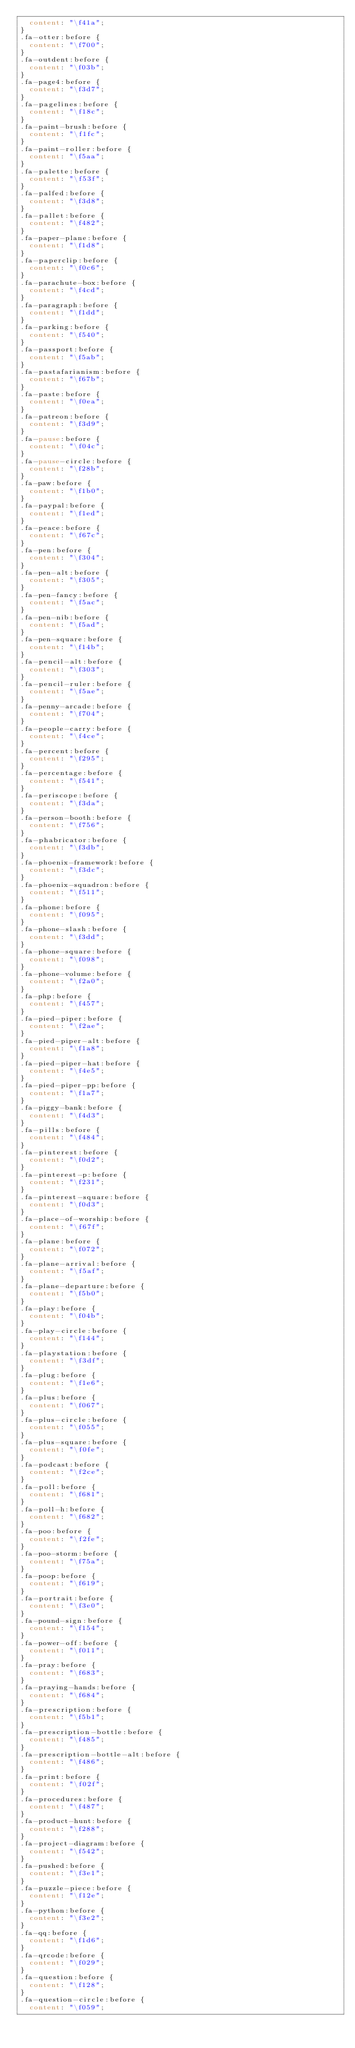Convert code to text. <code><loc_0><loc_0><loc_500><loc_500><_CSS_>  content: "\f41a";
}
.fa-otter:before {
  content: "\f700";
}
.fa-outdent:before {
  content: "\f03b";
}
.fa-page4:before {
  content: "\f3d7";
}
.fa-pagelines:before {
  content: "\f18c";
}
.fa-paint-brush:before {
  content: "\f1fc";
}
.fa-paint-roller:before {
  content: "\f5aa";
}
.fa-palette:before {
  content: "\f53f";
}
.fa-palfed:before {
  content: "\f3d8";
}
.fa-pallet:before {
  content: "\f482";
}
.fa-paper-plane:before {
  content: "\f1d8";
}
.fa-paperclip:before {
  content: "\f0c6";
}
.fa-parachute-box:before {
  content: "\f4cd";
}
.fa-paragraph:before {
  content: "\f1dd";
}
.fa-parking:before {
  content: "\f540";
}
.fa-passport:before {
  content: "\f5ab";
}
.fa-pastafarianism:before {
  content: "\f67b";
}
.fa-paste:before {
  content: "\f0ea";
}
.fa-patreon:before {
  content: "\f3d9";
}
.fa-pause:before {
  content: "\f04c";
}
.fa-pause-circle:before {
  content: "\f28b";
}
.fa-paw:before {
  content: "\f1b0";
}
.fa-paypal:before {
  content: "\f1ed";
}
.fa-peace:before {
  content: "\f67c";
}
.fa-pen:before {
  content: "\f304";
}
.fa-pen-alt:before {
  content: "\f305";
}
.fa-pen-fancy:before {
  content: "\f5ac";
}
.fa-pen-nib:before {
  content: "\f5ad";
}
.fa-pen-square:before {
  content: "\f14b";
}
.fa-pencil-alt:before {
  content: "\f303";
}
.fa-pencil-ruler:before {
  content: "\f5ae";
}
.fa-penny-arcade:before {
  content: "\f704";
}
.fa-people-carry:before {
  content: "\f4ce";
}
.fa-percent:before {
  content: "\f295";
}
.fa-percentage:before {
  content: "\f541";
}
.fa-periscope:before {
  content: "\f3da";
}
.fa-person-booth:before {
  content: "\f756";
}
.fa-phabricator:before {
  content: "\f3db";
}
.fa-phoenix-framework:before {
  content: "\f3dc";
}
.fa-phoenix-squadron:before {
  content: "\f511";
}
.fa-phone:before {
  content: "\f095";
}
.fa-phone-slash:before {
  content: "\f3dd";
}
.fa-phone-square:before {
  content: "\f098";
}
.fa-phone-volume:before {
  content: "\f2a0";
}
.fa-php:before {
  content: "\f457";
}
.fa-pied-piper:before {
  content: "\f2ae";
}
.fa-pied-piper-alt:before {
  content: "\f1a8";
}
.fa-pied-piper-hat:before {
  content: "\f4e5";
}
.fa-pied-piper-pp:before {
  content: "\f1a7";
}
.fa-piggy-bank:before {
  content: "\f4d3";
}
.fa-pills:before {
  content: "\f484";
}
.fa-pinterest:before {
  content: "\f0d2";
}
.fa-pinterest-p:before {
  content: "\f231";
}
.fa-pinterest-square:before {
  content: "\f0d3";
}
.fa-place-of-worship:before {
  content: "\f67f";
}
.fa-plane:before {
  content: "\f072";
}
.fa-plane-arrival:before {
  content: "\f5af";
}
.fa-plane-departure:before {
  content: "\f5b0";
}
.fa-play:before {
  content: "\f04b";
}
.fa-play-circle:before {
  content: "\f144";
}
.fa-playstation:before {
  content: "\f3df";
}
.fa-plug:before {
  content: "\f1e6";
}
.fa-plus:before {
  content: "\f067";
}
.fa-plus-circle:before {
  content: "\f055";
}
.fa-plus-square:before {
  content: "\f0fe";
}
.fa-podcast:before {
  content: "\f2ce";
}
.fa-poll:before {
  content: "\f681";
}
.fa-poll-h:before {
  content: "\f682";
}
.fa-poo:before {
  content: "\f2fe";
}
.fa-poo-storm:before {
  content: "\f75a";
}
.fa-poop:before {
  content: "\f619";
}
.fa-portrait:before {
  content: "\f3e0";
}
.fa-pound-sign:before {
  content: "\f154";
}
.fa-power-off:before {
  content: "\f011";
}
.fa-pray:before {
  content: "\f683";
}
.fa-praying-hands:before {
  content: "\f684";
}
.fa-prescription:before {
  content: "\f5b1";
}
.fa-prescription-bottle:before {
  content: "\f485";
}
.fa-prescription-bottle-alt:before {
  content: "\f486";
}
.fa-print:before {
  content: "\f02f";
}
.fa-procedures:before {
  content: "\f487";
}
.fa-product-hunt:before {
  content: "\f288";
}
.fa-project-diagram:before {
  content: "\f542";
}
.fa-pushed:before {
  content: "\f3e1";
}
.fa-puzzle-piece:before {
  content: "\f12e";
}
.fa-python:before {
  content: "\f3e2";
}
.fa-qq:before {
  content: "\f1d6";
}
.fa-qrcode:before {
  content: "\f029";
}
.fa-question:before {
  content: "\f128";
}
.fa-question-circle:before {
  content: "\f059";</code> 